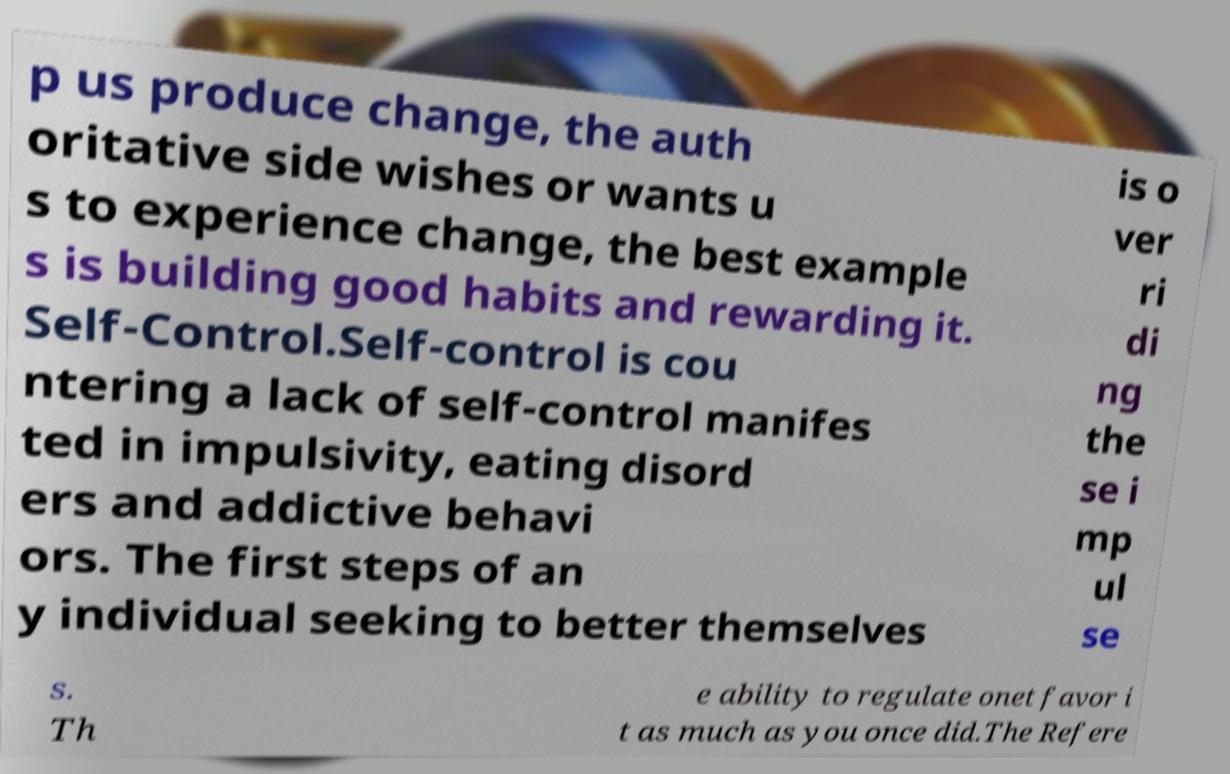Can you read and provide the text displayed in the image?This photo seems to have some interesting text. Can you extract and type it out for me? p us produce change, the auth oritative side wishes or wants u s to experience change, the best example s is building good habits and rewarding it. Self-Control.Self-control is cou ntering a lack of self-control manifes ted in impulsivity, eating disord ers and addictive behavi ors. The first steps of an y individual seeking to better themselves is o ver ri di ng the se i mp ul se s. Th e ability to regulate onet favor i t as much as you once did.The Refere 